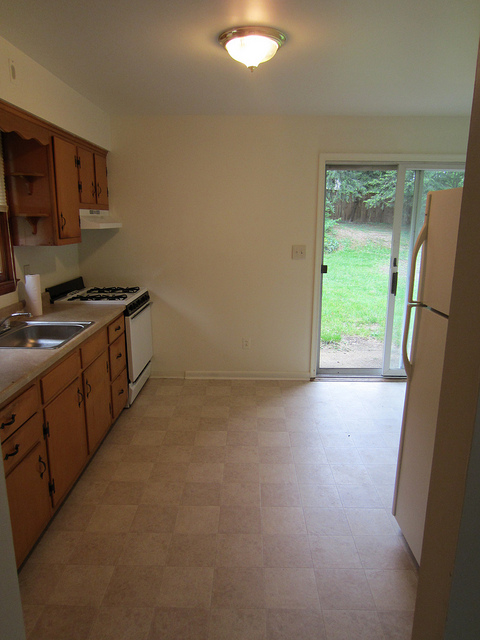<image>Does anyone dwell in the home? It is not clear if anyone dwells in the home. The answers vary between 'yes' and 'no'. What is the white object on the kitchen counter? I am not sure. The white object on the kitchen counter could be a mug, cup, paper towels or a candle. Does anyone dwell in the home? I don't know if anyone dwells in the home. It can be both no or yes. What is the white object on the kitchen counter? I don't know what the white object on the kitchen counter is. It could be a mug, cup, paper towels, paper towel roll, candle, or something else. 